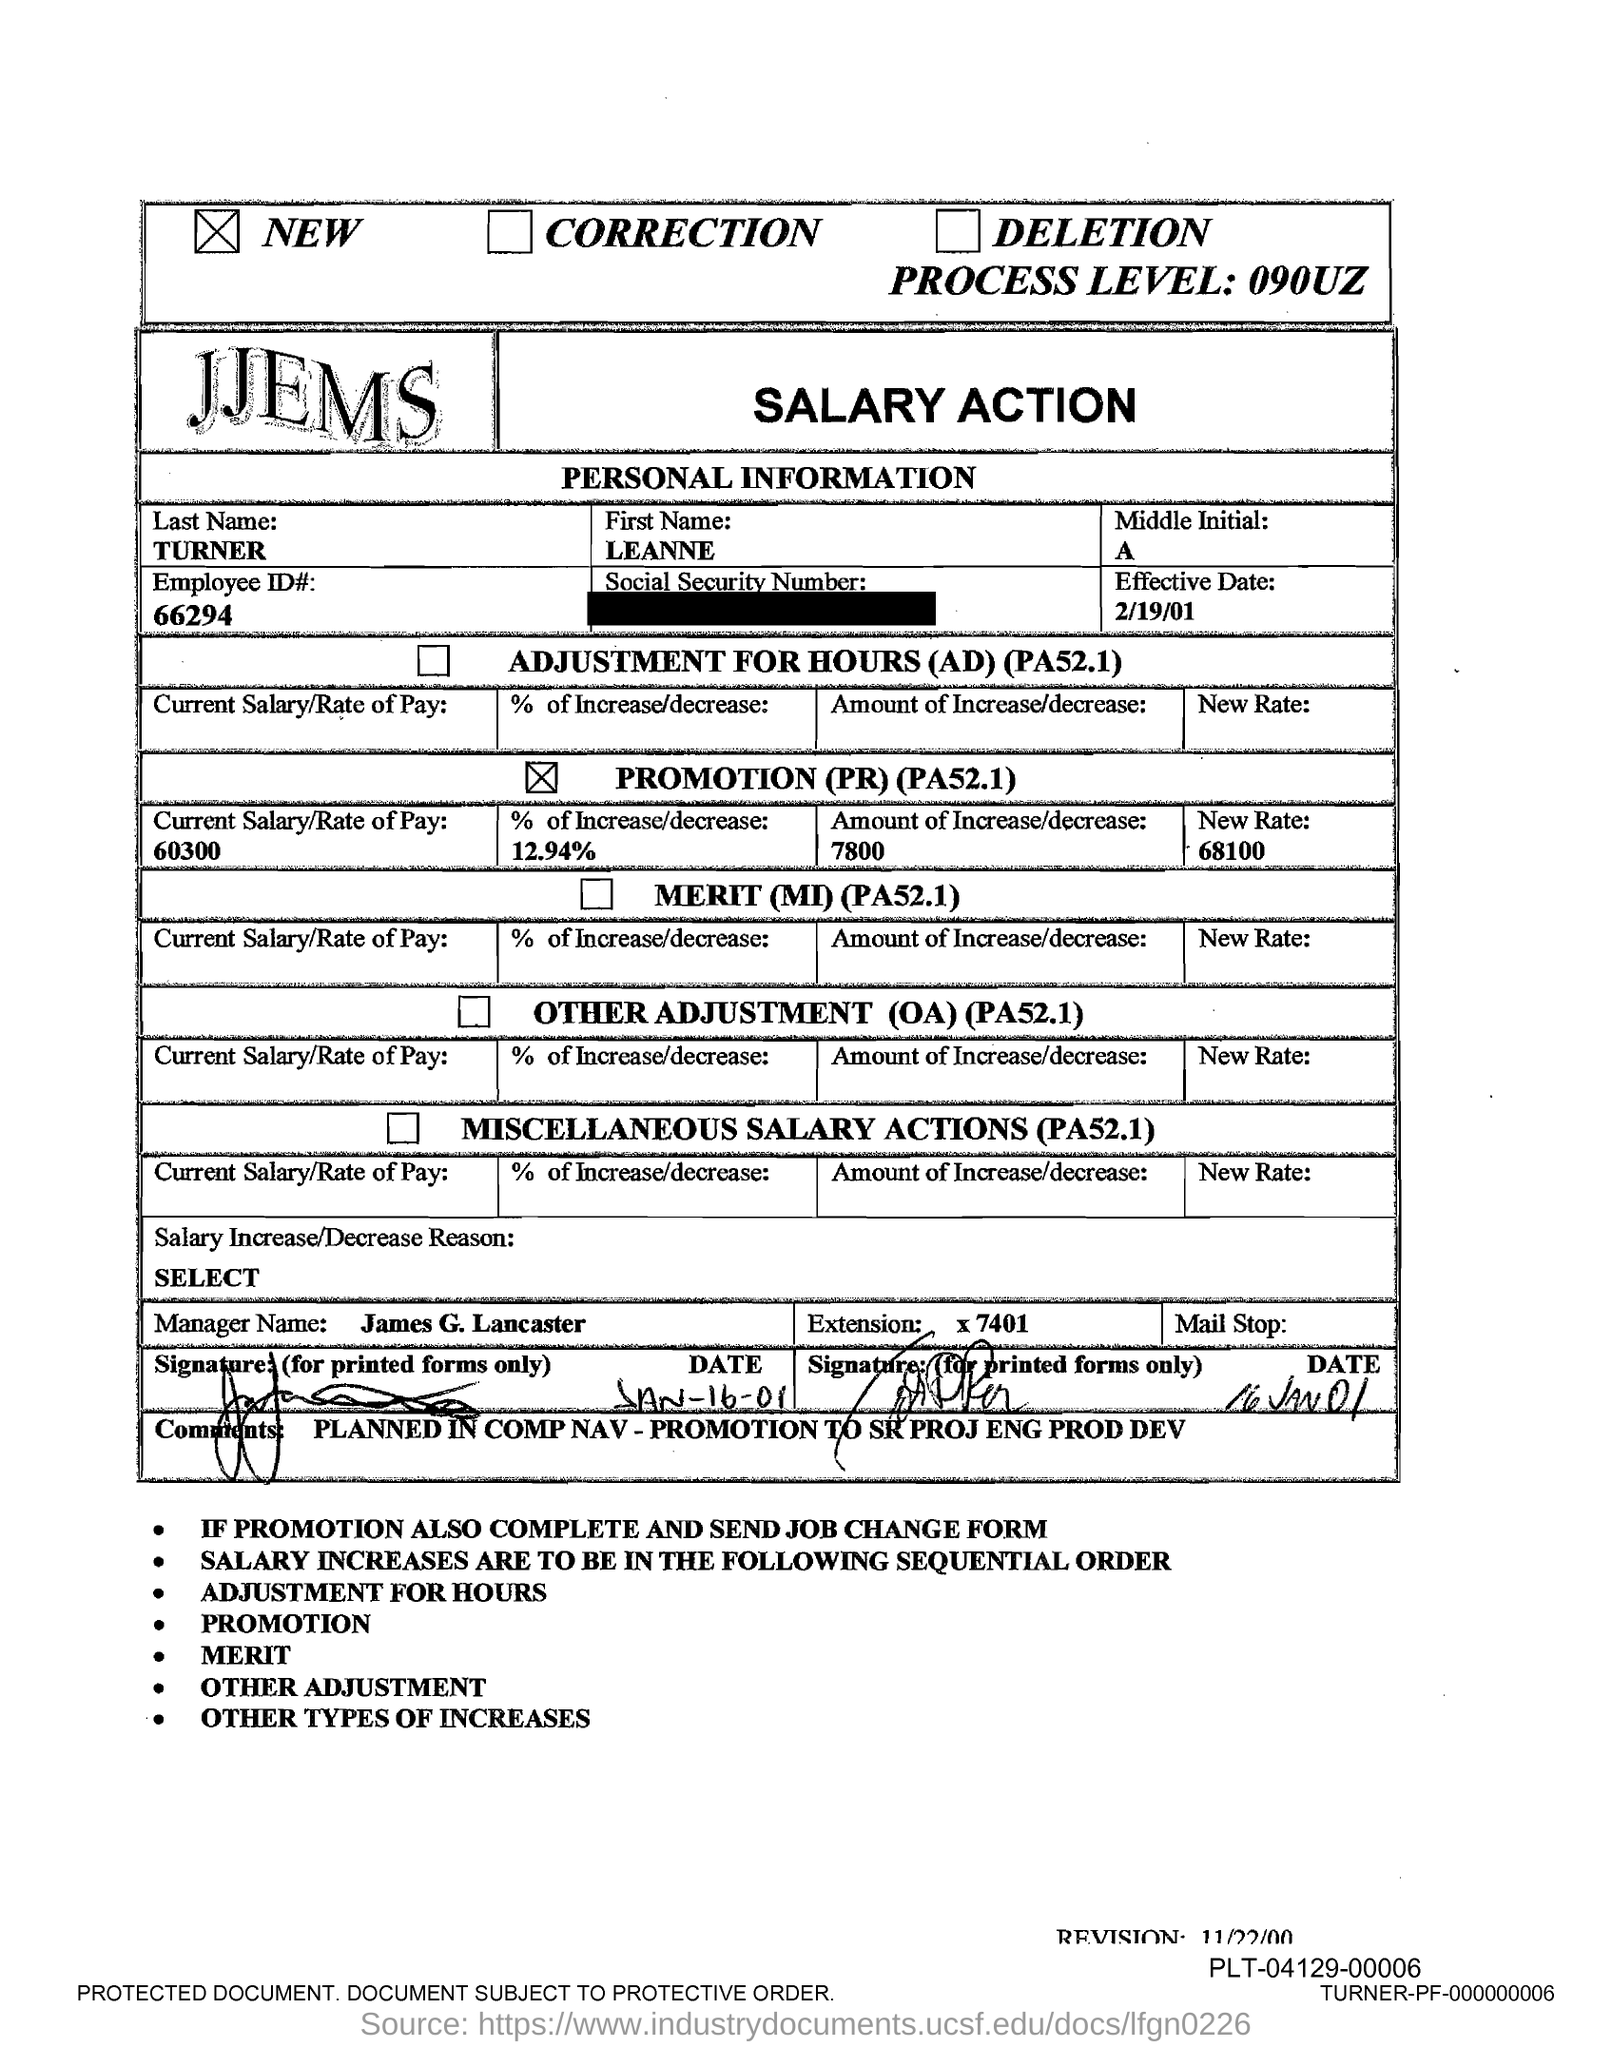Indicate a few pertinent items in this graphic. The employee ID number provided in the document is 66294. The effective date mentioned in this document is February 19, 2001. The employee's first name, as indicated in the document, is LEANNE. The manager's name mentioned in the document is James G. Lancaster. 